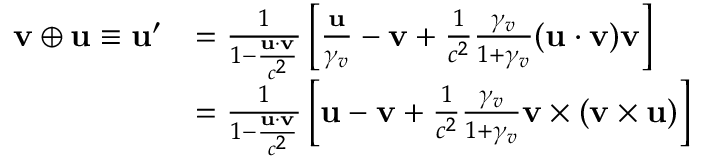<formula> <loc_0><loc_0><loc_500><loc_500>{ \begin{array} { r l } { v \oplus u \equiv u ^ { \prime } } & { = { \frac { 1 } { 1 - { \frac { u \cdot v } { c ^ { 2 } } } } } \left [ { \frac { u } { \gamma _ { v } } } - v + { \frac { 1 } { c ^ { 2 } } } { \frac { \gamma _ { v } } { 1 + \gamma _ { v } } } ( u \cdot v ) v \right ] } \\ & { = { \frac { 1 } { 1 - { \frac { u \cdot v } { c ^ { 2 } } } } } \left [ u - v + { \frac { 1 } { c ^ { 2 } } } { \frac { \gamma _ { v } } { 1 + \gamma _ { v } } } v \times ( v \times u ) \right ] } \end{array} }</formula> 